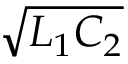<formula> <loc_0><loc_0><loc_500><loc_500>\sqrt { L _ { 1 } C _ { 2 } }</formula> 